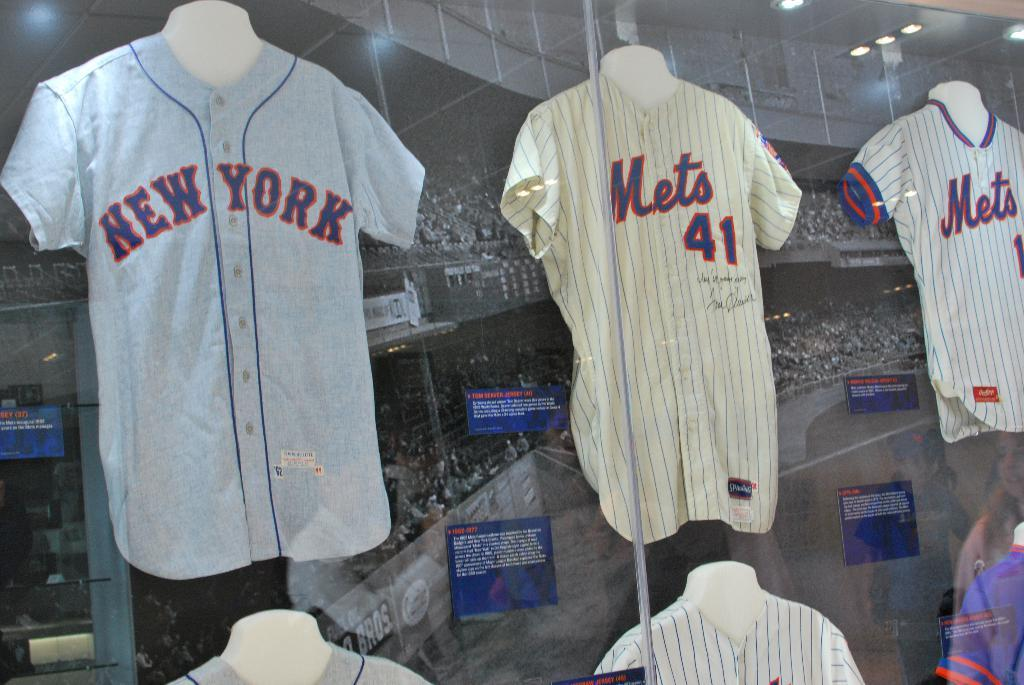<image>
Present a compact description of the photo's key features. Display of three New York Mets team jerseys 